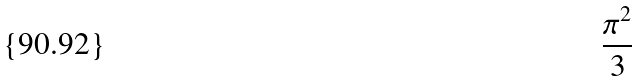Convert formula to latex. <formula><loc_0><loc_0><loc_500><loc_500>\frac { \pi ^ { 2 } } { 3 }</formula> 